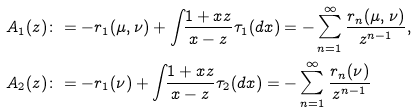Convert formula to latex. <formula><loc_0><loc_0><loc_500><loc_500>& A _ { 1 } ( z ) \colon = - r _ { 1 } ( \mu , \nu ) + \int _ { \real } \frac { 1 + x z } { x - z } \tau _ { 1 } ( d x ) = - \sum _ { n = 1 } ^ { \infty } \frac { r _ { n } ( \mu , \nu ) } { z ^ { n - 1 } } , \\ & A _ { 2 } ( z ) \colon = - r _ { 1 } ( \nu ) + \int _ { \real } \frac { 1 + x z } { x - z } \tau _ { 2 } ( d x ) = - \sum _ { n = 1 } ^ { \infty } \frac { r _ { n } ( \nu ) } { z ^ { n - 1 } }</formula> 